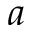<formula> <loc_0><loc_0><loc_500><loc_500>a</formula> 